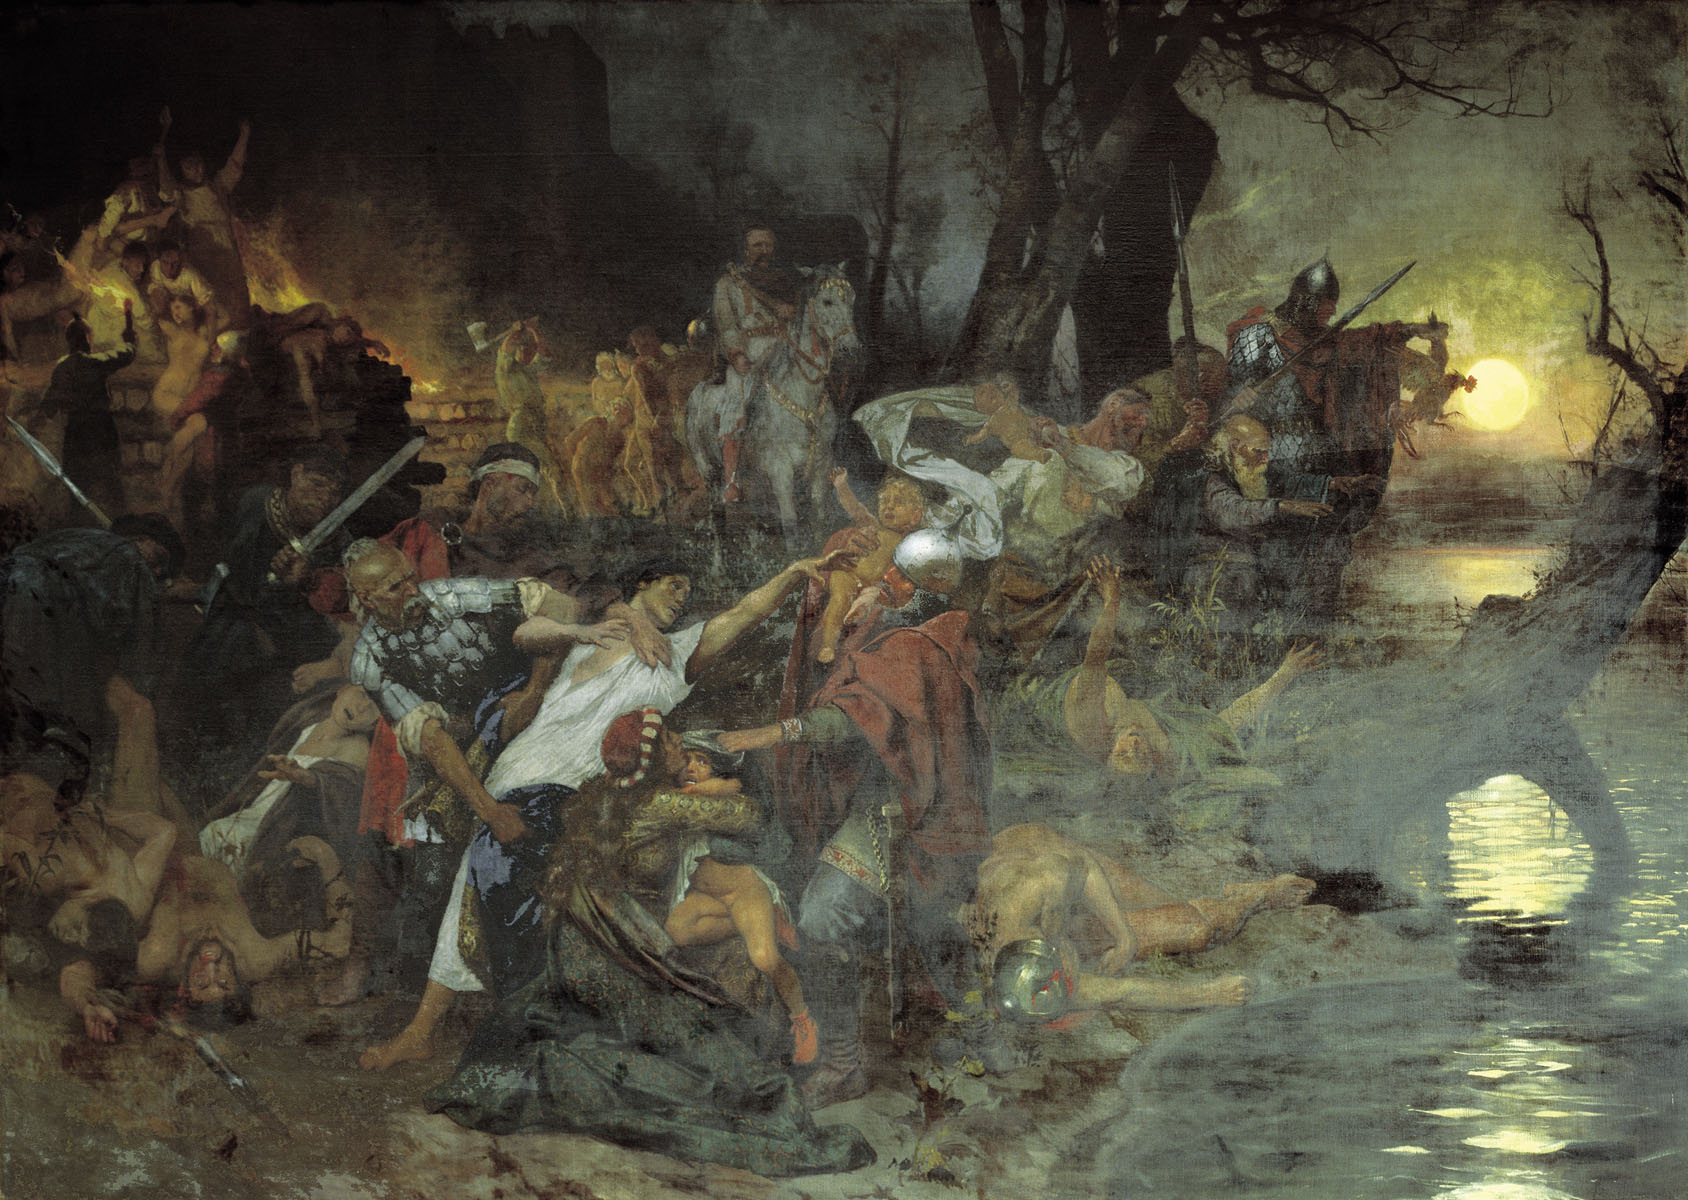Describe the expressions and emotions of the figures in the painting. The expressions of the figures in the painting depict a range of intense emotions. Some faces display sheer determination and aggression, eyes glaring and mouths open wide with battle cries. Others, caught in moments of pain and fear, show wide-eyed terror and suffering. The turmoil of the scene is palpable, with soldiers grimacing in their final moments and comrades showing desperation as they fend off their enemies. The artist has meticulously captured the emotional spectrum of the battle, emphasizing the humanity amidst the chaos. How do the surrounding elements like the ruins and trees contribute to the overall impact of the painting? The surrounding elements like the ruins and trees significantly enhance the overall impact of the painting by providing context and atmosphere. The ruins suggest a place once full of life, now devastated by the ravages of war, adding a layer of tragedy to the scene. The gnarled, bare trees contribute to the bleak and somber mood, their twisted forms echoing the chaos and violence below. These elements together create a vivid, immersive environment that underscores the destruction and desolation brought forth by the battle, amplifying the viewer’s emotional response to the painting. Imagine you are one of the warriors in this scene. What are your thoughts and feelings at this moment? As a warrior in this chaotic scene, my thoughts and feelings are a tumultuous mix of fear, determination, and adrenaline. The cries of battle and the clash of weapons are deafening around me. I am acutely aware of the danger, knowing that every move could be my last. Amidst the fog of war, I feel an indescribable connection to my comrades, fighting for each other’s survival. The sight of the moon in the sky offers a strange sense of calm and hope, yet the violence around me demands my full attention and strength. The blood, sweat, and relentless struggle for life and death dominate my every thought and feeling in this harrowing moment. 